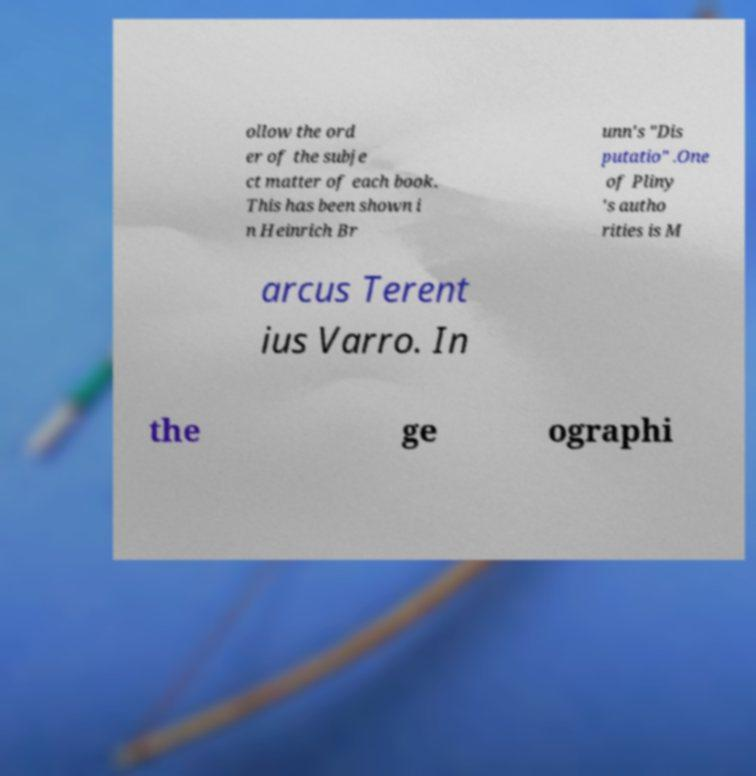Can you read and provide the text displayed in the image?This photo seems to have some interesting text. Can you extract and type it out for me? ollow the ord er of the subje ct matter of each book. This has been shown i n Heinrich Br unn's "Dis putatio" .One of Pliny 's autho rities is M arcus Terent ius Varro. In the ge ographi 